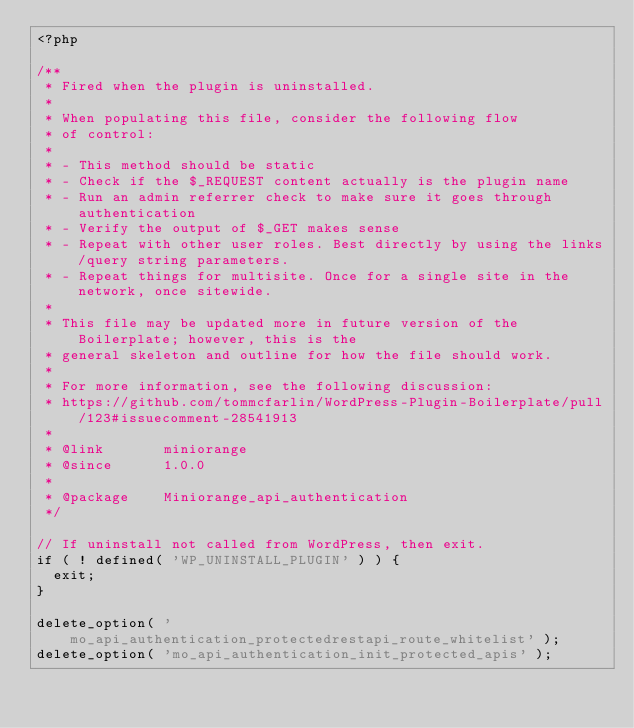<code> <loc_0><loc_0><loc_500><loc_500><_PHP_><?php

/**
 * Fired when the plugin is uninstalled.
 *
 * When populating this file, consider the following flow
 * of control:
 *
 * - This method should be static
 * - Check if the $_REQUEST content actually is the plugin name
 * - Run an admin referrer check to make sure it goes through authentication
 * - Verify the output of $_GET makes sense
 * - Repeat with other user roles. Best directly by using the links/query string parameters.
 * - Repeat things for multisite. Once for a single site in the network, once sitewide.
 *
 * This file may be updated more in future version of the Boilerplate; however, this is the
 * general skeleton and outline for how the file should work.
 *
 * For more information, see the following discussion:
 * https://github.com/tommcfarlin/WordPress-Plugin-Boilerplate/pull/123#issuecomment-28541913
 *
 * @link       miniorange
 * @since      1.0.0
 *
 * @package    Miniorange_api_authentication
 */

// If uninstall not called from WordPress, then exit.
if ( ! defined( 'WP_UNINSTALL_PLUGIN' ) ) {
	exit;
}

delete_option( 'mo_api_authentication_protectedrestapi_route_whitelist' );
delete_option( 'mo_api_authentication_init_protected_apis' );
</code> 